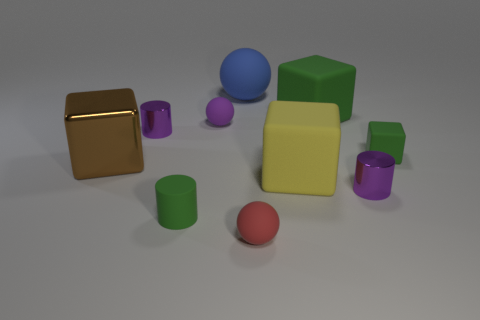Subtract all cyan spheres. Subtract all blue blocks. How many spheres are left? 3 Subtract all cylinders. How many objects are left? 7 Subtract all large purple metal objects. Subtract all tiny red rubber spheres. How many objects are left? 9 Add 1 small purple shiny cylinders. How many small purple shiny cylinders are left? 3 Add 7 tiny green rubber objects. How many tiny green rubber objects exist? 9 Subtract 1 green cylinders. How many objects are left? 9 